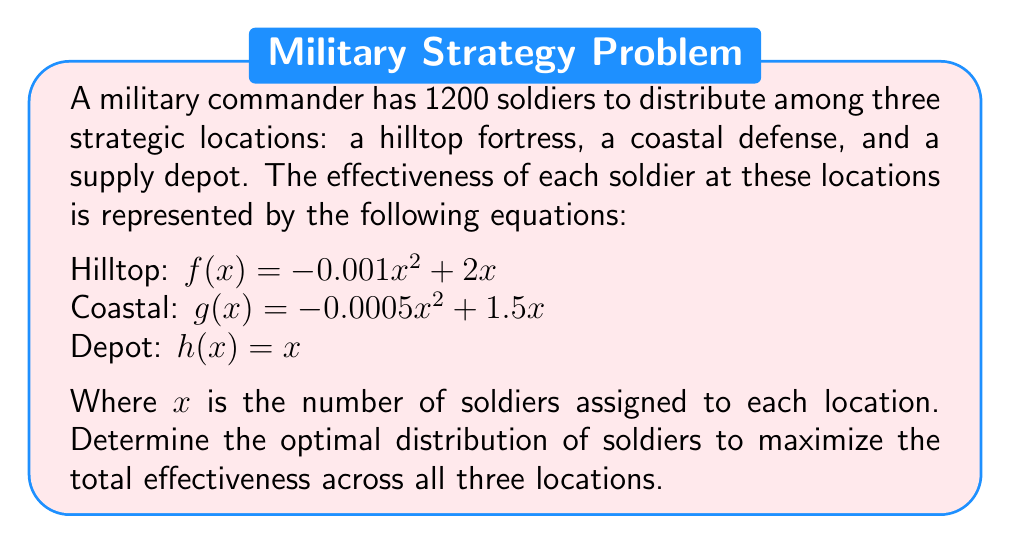Teach me how to tackle this problem. 1) To maximize total effectiveness, we need to find the point where the marginal effectiveness of adding a soldier is equal across all locations. This occurs when the derivatives of each function are equal.

2) Calculate the derivatives:
   $f'(x) = -0.002x + 2$
   $g'(x) = -0.001x + 1.5$
   $h'(x) = 1$

3) Set the derivatives equal to each other:
   $-0.002x + 2 = -0.001y + 1.5 = 1$

4) Solve for $x$ and $y$:
   $-0.002x + 2 = 1$
   $-0.002x = -1$
   $x = 500$ (Hilltop)

   $-0.001y + 1.5 = 1$
   $-0.001y = -0.5$
   $y = 500$ (Coastal)

5) The remaining soldiers go to the depot:
   $1200 - 500 - 500 = 200$ (Depot)

6) Verify the total:
   $500 + 500 + 200 = 1200$

7) Calculate the total effectiveness:
   Hilltop: $f(500) = -0.001(500)^2 + 2(500) = 750$
   Coastal: $g(500) = -0.0005(500)^2 + 1.5(500) = 625$
   Depot: $h(200) = 200$
   Total: $750 + 625 + 200 = 1575$
Answer: Hilltop: 500, Coastal: 500, Depot: 200 